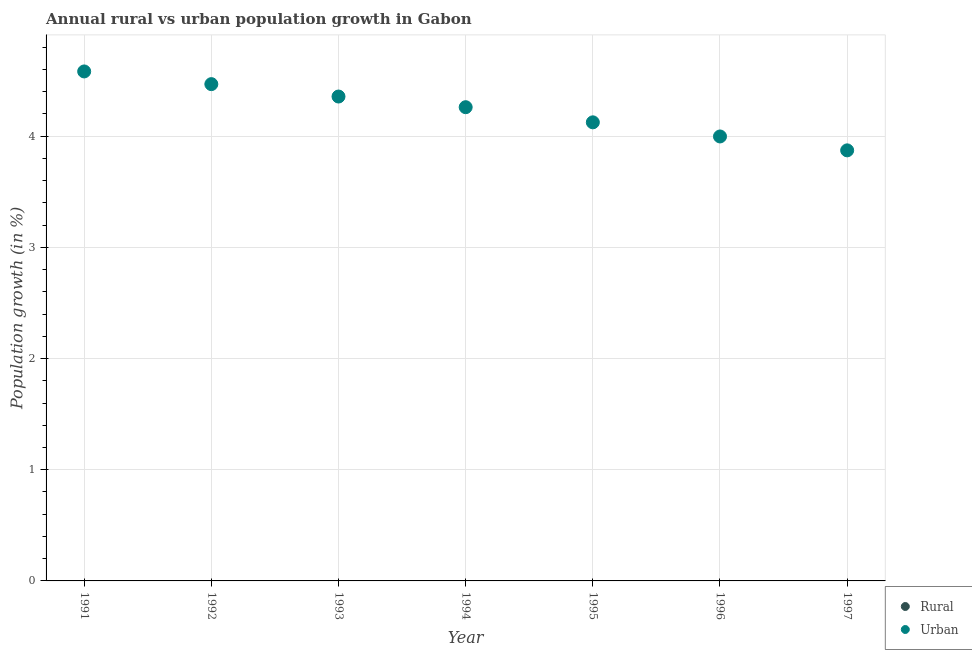How many different coloured dotlines are there?
Offer a terse response. 1. Across all years, what is the maximum urban population growth?
Offer a very short reply. 4.58. Across all years, what is the minimum urban population growth?
Give a very brief answer. 3.87. In which year was the urban population growth maximum?
Your answer should be compact. 1991. What is the total urban population growth in the graph?
Ensure brevity in your answer.  29.66. What is the difference between the urban population growth in 1996 and that in 1997?
Provide a short and direct response. 0.12. What is the difference between the rural population growth in 1996 and the urban population growth in 1995?
Keep it short and to the point. -4.12. What is the average urban population growth per year?
Offer a terse response. 4.24. In how many years, is the rural population growth greater than 2 %?
Your answer should be very brief. 0. What is the ratio of the urban population growth in 1991 to that in 1994?
Your answer should be compact. 1.08. Is the urban population growth in 1992 less than that in 1996?
Keep it short and to the point. No. What is the difference between the highest and the second highest urban population growth?
Your answer should be very brief. 0.11. What is the difference between the highest and the lowest urban population growth?
Keep it short and to the point. 0.71. In how many years, is the urban population growth greater than the average urban population growth taken over all years?
Your response must be concise. 4. Is the sum of the urban population growth in 1995 and 1996 greater than the maximum rural population growth across all years?
Provide a succinct answer. Yes. Does the urban population growth monotonically increase over the years?
Your response must be concise. No. Is the rural population growth strictly less than the urban population growth over the years?
Your answer should be very brief. Yes. How many dotlines are there?
Keep it short and to the point. 1. How many years are there in the graph?
Your answer should be compact. 7. What is the difference between two consecutive major ticks on the Y-axis?
Provide a short and direct response. 1. Does the graph contain any zero values?
Keep it short and to the point. Yes. Does the graph contain grids?
Your answer should be very brief. Yes. How many legend labels are there?
Provide a succinct answer. 2. What is the title of the graph?
Your answer should be compact. Annual rural vs urban population growth in Gabon. What is the label or title of the X-axis?
Your response must be concise. Year. What is the label or title of the Y-axis?
Provide a succinct answer. Population growth (in %). What is the Population growth (in %) in Urban  in 1991?
Ensure brevity in your answer.  4.58. What is the Population growth (in %) of Urban  in 1992?
Make the answer very short. 4.47. What is the Population growth (in %) in Rural in 1993?
Provide a succinct answer. 0. What is the Population growth (in %) of Urban  in 1993?
Your response must be concise. 4.36. What is the Population growth (in %) of Rural in 1994?
Ensure brevity in your answer.  0. What is the Population growth (in %) of Urban  in 1994?
Give a very brief answer. 4.26. What is the Population growth (in %) in Urban  in 1995?
Your response must be concise. 4.12. What is the Population growth (in %) in Urban  in 1996?
Keep it short and to the point. 4. What is the Population growth (in %) of Urban  in 1997?
Provide a short and direct response. 3.87. Across all years, what is the maximum Population growth (in %) of Urban ?
Keep it short and to the point. 4.58. Across all years, what is the minimum Population growth (in %) in Urban ?
Offer a very short reply. 3.87. What is the total Population growth (in %) of Urban  in the graph?
Make the answer very short. 29.66. What is the difference between the Population growth (in %) of Urban  in 1991 and that in 1992?
Provide a succinct answer. 0.11. What is the difference between the Population growth (in %) in Urban  in 1991 and that in 1993?
Offer a very short reply. 0.23. What is the difference between the Population growth (in %) in Urban  in 1991 and that in 1994?
Offer a very short reply. 0.32. What is the difference between the Population growth (in %) of Urban  in 1991 and that in 1995?
Your answer should be very brief. 0.46. What is the difference between the Population growth (in %) of Urban  in 1991 and that in 1996?
Your response must be concise. 0.58. What is the difference between the Population growth (in %) of Urban  in 1991 and that in 1997?
Make the answer very short. 0.71. What is the difference between the Population growth (in %) in Urban  in 1992 and that in 1993?
Offer a terse response. 0.11. What is the difference between the Population growth (in %) of Urban  in 1992 and that in 1994?
Make the answer very short. 0.21. What is the difference between the Population growth (in %) of Urban  in 1992 and that in 1995?
Make the answer very short. 0.34. What is the difference between the Population growth (in %) of Urban  in 1992 and that in 1996?
Offer a very short reply. 0.47. What is the difference between the Population growth (in %) of Urban  in 1992 and that in 1997?
Make the answer very short. 0.6. What is the difference between the Population growth (in %) of Urban  in 1993 and that in 1994?
Provide a short and direct response. 0.1. What is the difference between the Population growth (in %) of Urban  in 1993 and that in 1995?
Make the answer very short. 0.23. What is the difference between the Population growth (in %) in Urban  in 1993 and that in 1996?
Provide a short and direct response. 0.36. What is the difference between the Population growth (in %) in Urban  in 1993 and that in 1997?
Provide a short and direct response. 0.48. What is the difference between the Population growth (in %) of Urban  in 1994 and that in 1995?
Offer a very short reply. 0.14. What is the difference between the Population growth (in %) in Urban  in 1994 and that in 1996?
Offer a terse response. 0.26. What is the difference between the Population growth (in %) of Urban  in 1994 and that in 1997?
Make the answer very short. 0.39. What is the difference between the Population growth (in %) in Urban  in 1995 and that in 1996?
Offer a very short reply. 0.13. What is the difference between the Population growth (in %) of Urban  in 1995 and that in 1997?
Offer a terse response. 0.25. What is the average Population growth (in %) in Rural per year?
Give a very brief answer. 0. What is the average Population growth (in %) in Urban  per year?
Provide a succinct answer. 4.24. What is the ratio of the Population growth (in %) of Urban  in 1991 to that in 1992?
Your answer should be very brief. 1.03. What is the ratio of the Population growth (in %) of Urban  in 1991 to that in 1993?
Provide a succinct answer. 1.05. What is the ratio of the Population growth (in %) of Urban  in 1991 to that in 1994?
Ensure brevity in your answer.  1.08. What is the ratio of the Population growth (in %) of Urban  in 1991 to that in 1995?
Keep it short and to the point. 1.11. What is the ratio of the Population growth (in %) of Urban  in 1991 to that in 1996?
Provide a short and direct response. 1.15. What is the ratio of the Population growth (in %) of Urban  in 1991 to that in 1997?
Offer a terse response. 1.18. What is the ratio of the Population growth (in %) of Urban  in 1992 to that in 1993?
Keep it short and to the point. 1.03. What is the ratio of the Population growth (in %) in Urban  in 1992 to that in 1994?
Make the answer very short. 1.05. What is the ratio of the Population growth (in %) of Urban  in 1992 to that in 1995?
Provide a short and direct response. 1.08. What is the ratio of the Population growth (in %) of Urban  in 1992 to that in 1996?
Your answer should be compact. 1.12. What is the ratio of the Population growth (in %) of Urban  in 1992 to that in 1997?
Ensure brevity in your answer.  1.15. What is the ratio of the Population growth (in %) of Urban  in 1993 to that in 1994?
Keep it short and to the point. 1.02. What is the ratio of the Population growth (in %) of Urban  in 1993 to that in 1995?
Keep it short and to the point. 1.06. What is the ratio of the Population growth (in %) in Urban  in 1993 to that in 1996?
Your answer should be compact. 1.09. What is the ratio of the Population growth (in %) of Urban  in 1993 to that in 1997?
Offer a terse response. 1.12. What is the ratio of the Population growth (in %) of Urban  in 1994 to that in 1995?
Your response must be concise. 1.03. What is the ratio of the Population growth (in %) in Urban  in 1994 to that in 1996?
Offer a terse response. 1.07. What is the ratio of the Population growth (in %) in Urban  in 1994 to that in 1997?
Offer a very short reply. 1.1. What is the ratio of the Population growth (in %) in Urban  in 1995 to that in 1996?
Offer a very short reply. 1.03. What is the ratio of the Population growth (in %) in Urban  in 1995 to that in 1997?
Make the answer very short. 1.07. What is the ratio of the Population growth (in %) of Urban  in 1996 to that in 1997?
Provide a short and direct response. 1.03. What is the difference between the highest and the second highest Population growth (in %) in Urban ?
Your answer should be compact. 0.11. What is the difference between the highest and the lowest Population growth (in %) in Urban ?
Your response must be concise. 0.71. 